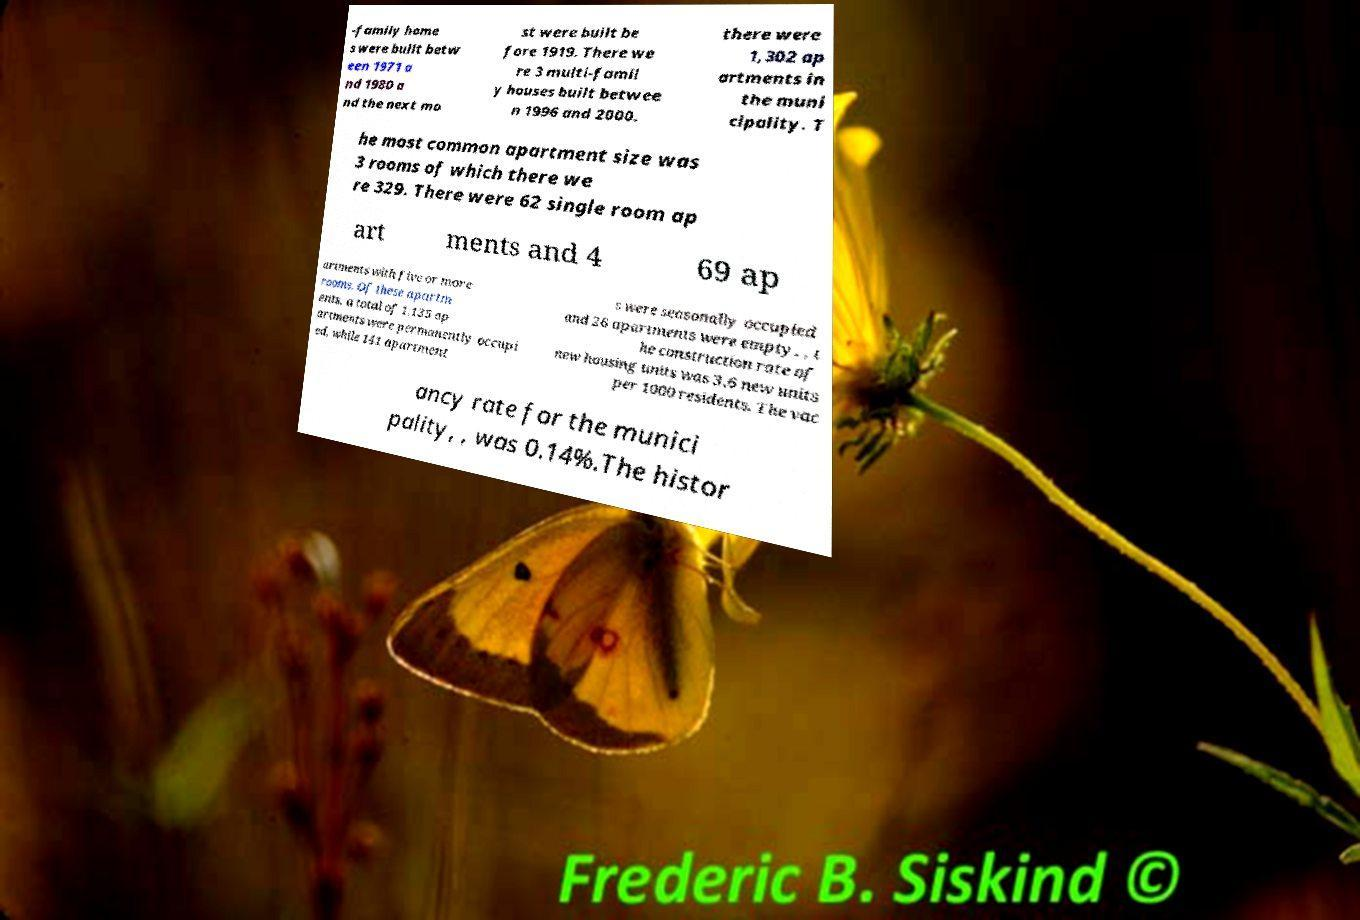Please identify and transcribe the text found in this image. -family home s were built betw een 1971 a nd 1980 a nd the next mo st were built be fore 1919. There we re 3 multi-famil y houses built betwee n 1996 and 2000. there were 1,302 ap artments in the muni cipality. T he most common apartment size was 3 rooms of which there we re 329. There were 62 single room ap art ments and 4 69 ap artments with five or more rooms. Of these apartm ents, a total of 1,135 ap artments were permanently occupi ed, while 141 apartment s were seasonally occupied and 26 apartments were empty. , t he construction rate of new housing units was 3.6 new units per 1000 residents. The vac ancy rate for the munici pality, , was 0.14%.The histor 